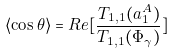<formula> <loc_0><loc_0><loc_500><loc_500>\langle \cos \theta \rangle = R e [ \frac { T _ { 1 , 1 } ( a ^ { A } _ { 1 } ) } { T _ { 1 , 1 } ( \Phi _ { \gamma } ) } ]</formula> 